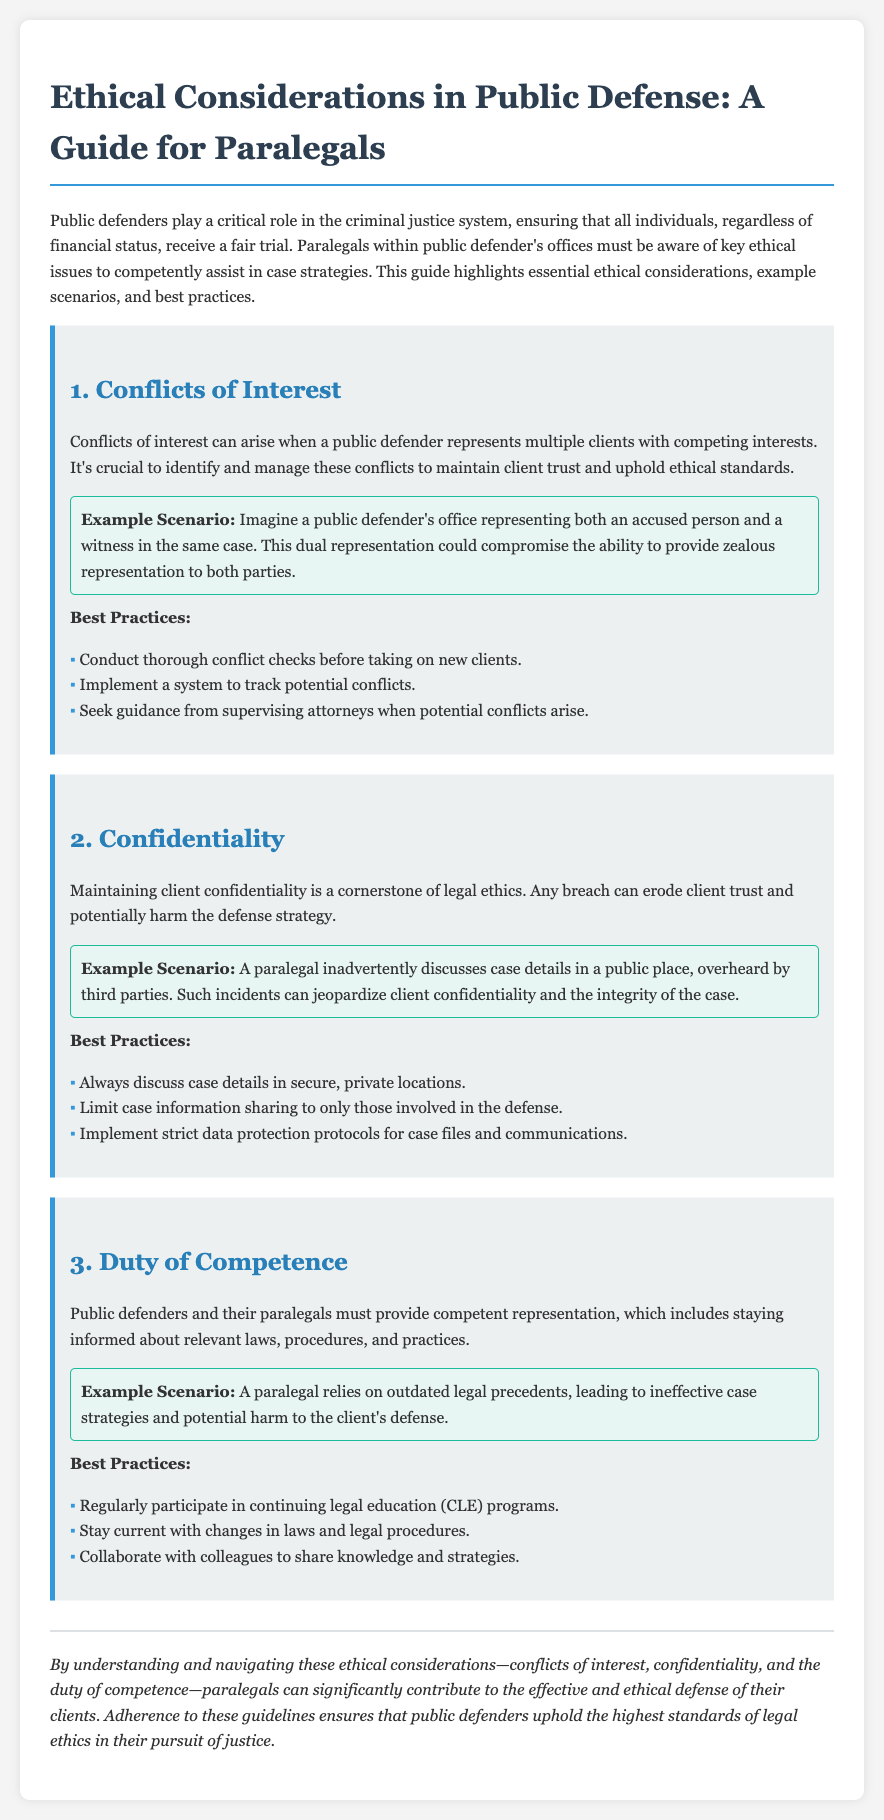What is the primary role of public defenders? The primary role of public defenders is to ensure that all individuals, regardless of financial status, receive a fair trial.
Answer: fair trial What is one key ethical issue related to public defense? One key ethical issue related to public defense highlighted in the document is conflicts of interest.
Answer: conflicts of interest What should public defenders conduct before taking on new clients? Public defenders should conduct thorough conflict checks before taking on new clients.
Answer: conflict checks In the confidentiality section, what can jeopardize client confidentiality? Inadvertently discussing case details in a public place can jeopardize client confidentiality.
Answer: discussing case details What is a recommended best practice regarding the duty of competence? A recommended best practice is to regularly participate in continuing legal education programs.
Answer: continuing legal education How can a paralegal compromise the ability to provide zealous representation? A paralegal can compromise the ability to provide zealous representation by representing multiple clients with competing interests.
Answer: representing multiple clients What is the potential consequence of relying on outdated legal precedents? The potential consequence of relying on outdated legal precedents is ineffective case strategies and potential harm to the client's defense.
Answer: ineffective case strategies What color is used for the section titles in the document? The section titles in the document use the color blue.
Answer: blue 